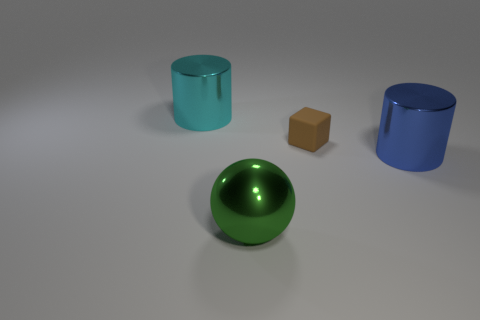Can you describe the textures of the objects? Certainly! The green ball and the cylindrical objects have a smooth, highly reflective surface that suggests they are polished or have a glossy finish. The brown cube, on the other hand, appears to have a matte surface, which might indicate a more porous material like wood or a non-reflective plastic. 